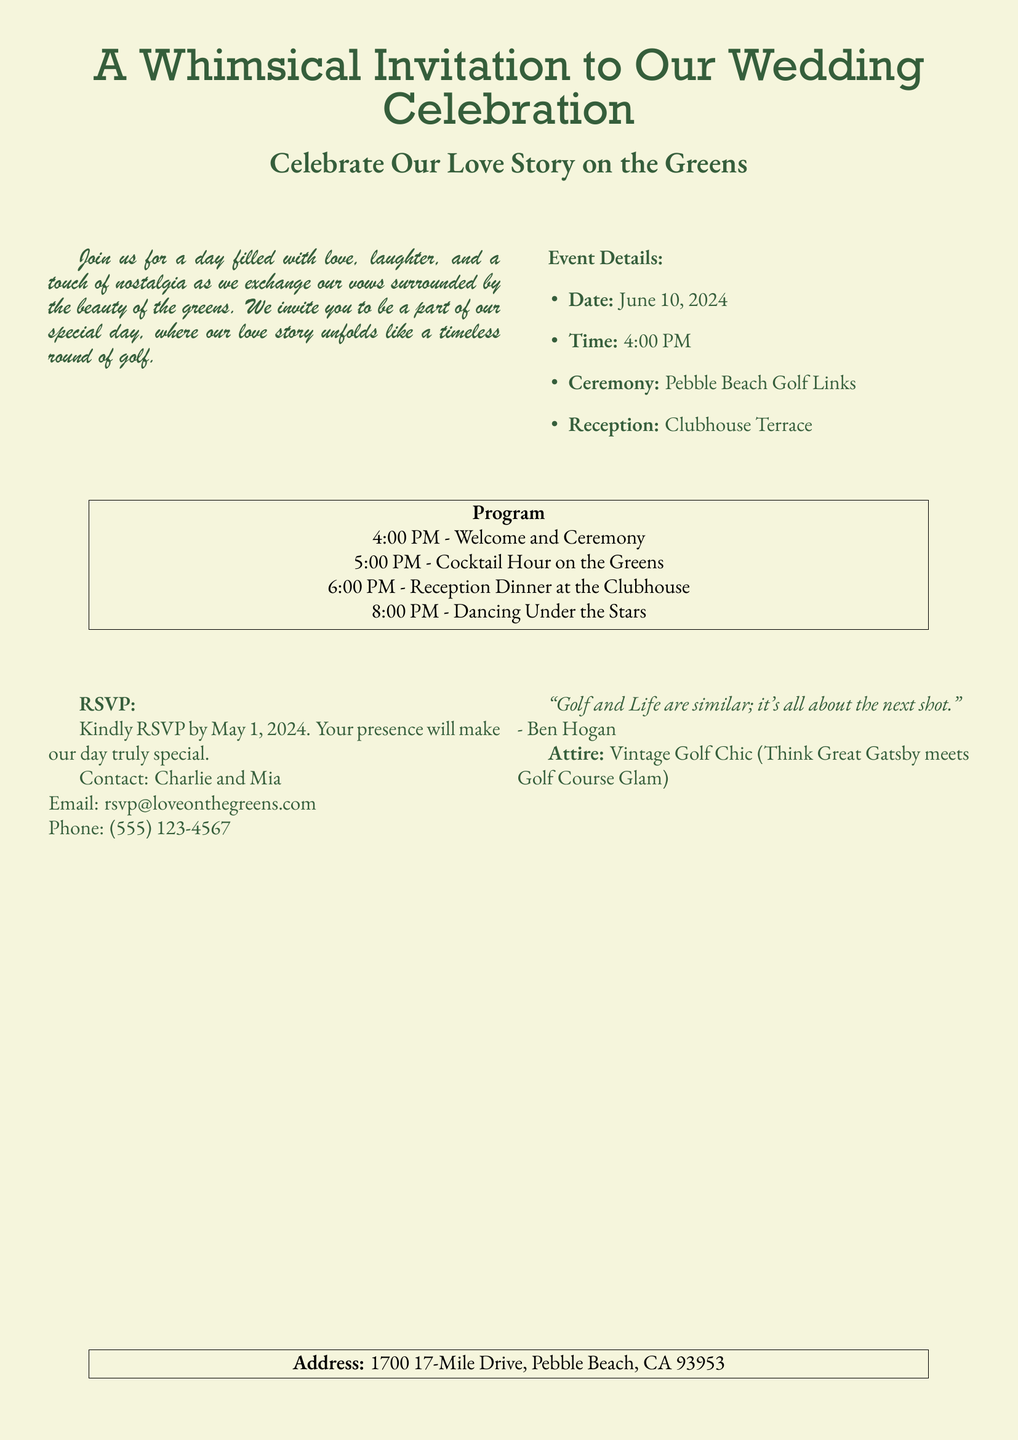What is the date of the wedding? The date of the wedding is explicitly stated in the invitation.
Answer: June 10, 2024 What time does the ceremony start? The invitation provides a specific time for the ceremony.
Answer: 4:00 PM Where is the ceremony taking place? The location of the ceremony is mentioned in the event details.
Answer: Pebble Beach Golf Links What is the theme of the attire? The invitation specifies a unique dress code for the guests.
Answer: Vintage Golf Chic Who should guests contact to RSVP? The invitation includes the names of the couple for RSVP contacts.
Answer: Charlie and Mia What is the RSVP deadline? The document clearly states the date by which guests should RSVP.
Answer: May 1, 2024 What is included in the program? The invitation outlines the specific activities scheduled for the event.
Answer: Welcome and Ceremony, Cocktail Hour, Reception Dinner, Dancing Under the Stars What sentiment is expressed about golf and life? An inspirational quote related to golf is provided in the document.
Answer: "Golf and Life are similar; it's all about the next shot." What type of events will take place after the ceremony? The program section lists activities planned after the ceremony.
Answer: Cocktail Hour, Reception Dinner, Dancing Under the Stars 